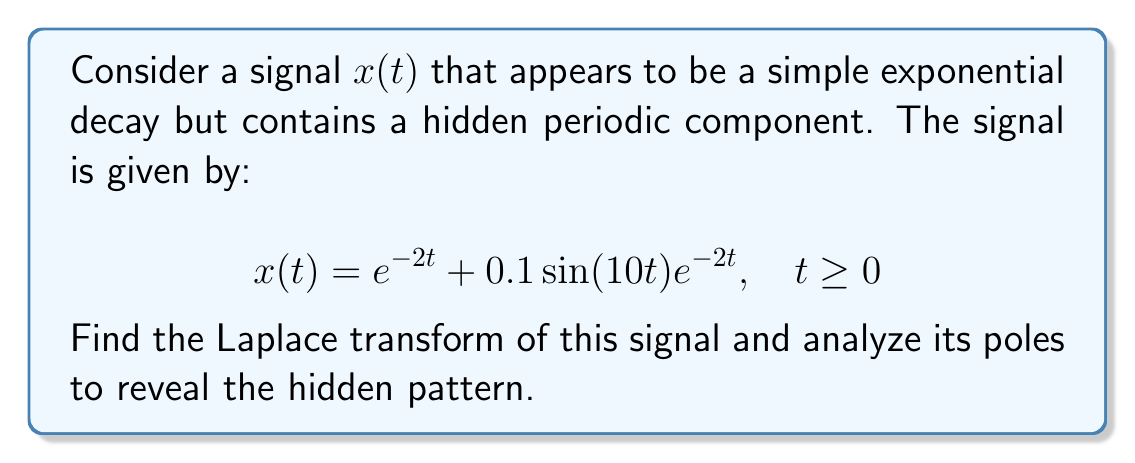Show me your answer to this math problem. Let's approach this step-by-step:

1) The Laplace transform of $x(t)$ is given by:

   $$X(s) = \mathcal{L}\{x(t)\} = \int_0^\infty x(t)e^{-st}dt$$

2) We can split this into two parts:
   
   $$X(s) = \mathcal{L}\{e^{-2t}\} + 0.1\mathcal{L}\{\sin(10t)e^{-2t}\}$$

3) For the first part, we know that:
   
   $$\mathcal{L}\{e^{-at}\} = \frac{1}{s+a}$$

   So, $\mathcal{L}\{e^{-2t}\} = \frac{1}{s+2}$

4) For the second part, we can use the frequency shifting property:
   
   $$\mathcal{L}\{e^{-at}\sin(bt)\} = \frac{b}{(s+a)^2 + b^2}$$

   Here, $a=2$ and $b=10$

5) Putting it all together:

   $$X(s) = \frac{1}{s+2} + 0.1\frac{10}{(s+2)^2 + 100}$$

6) Simplifying:

   $$X(s) = \frac{1}{s+2} + \frac{1}{(s+2)^2 + 100}$$

7) The poles of this function are at $s = -2$ and $s = -2 \pm 10i$

8) The pole at $s = -2$ corresponds to the exponential decay.
   The complex conjugate poles at $s = -2 \pm 10i$ reveal the hidden sinusoidal component with frequency 10 rad/s.
Answer: The Laplace transform of the signal is:

$$X(s) = \frac{1}{s+2} + \frac{1}{(s+2)^2 + 100}$$

The poles at $s = -2$ and $s = -2 \pm 10i$ reveal the exponential decay and the hidden sinusoidal component with frequency 10 rad/s. 